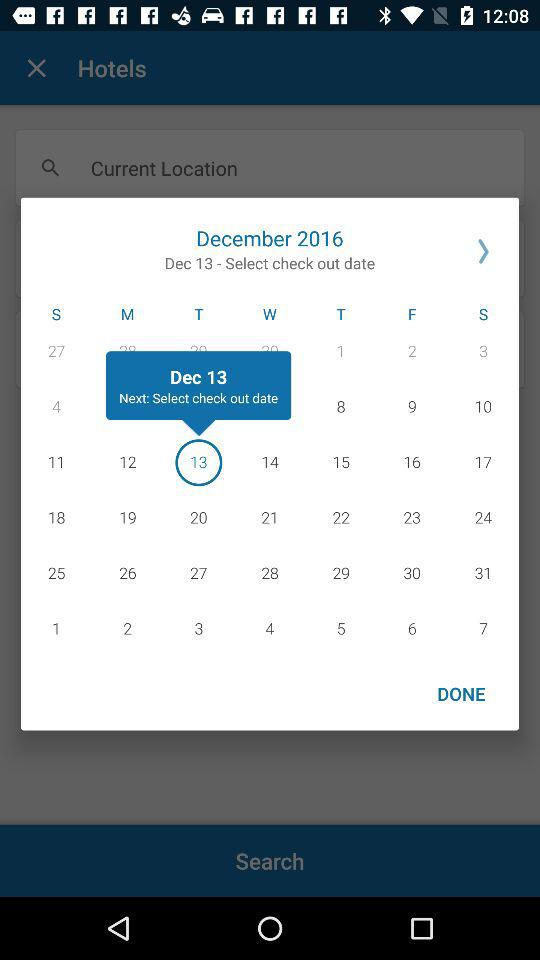Which date is selected for check in?
When the provided information is insufficient, respond with <no answer>. <no answer> 